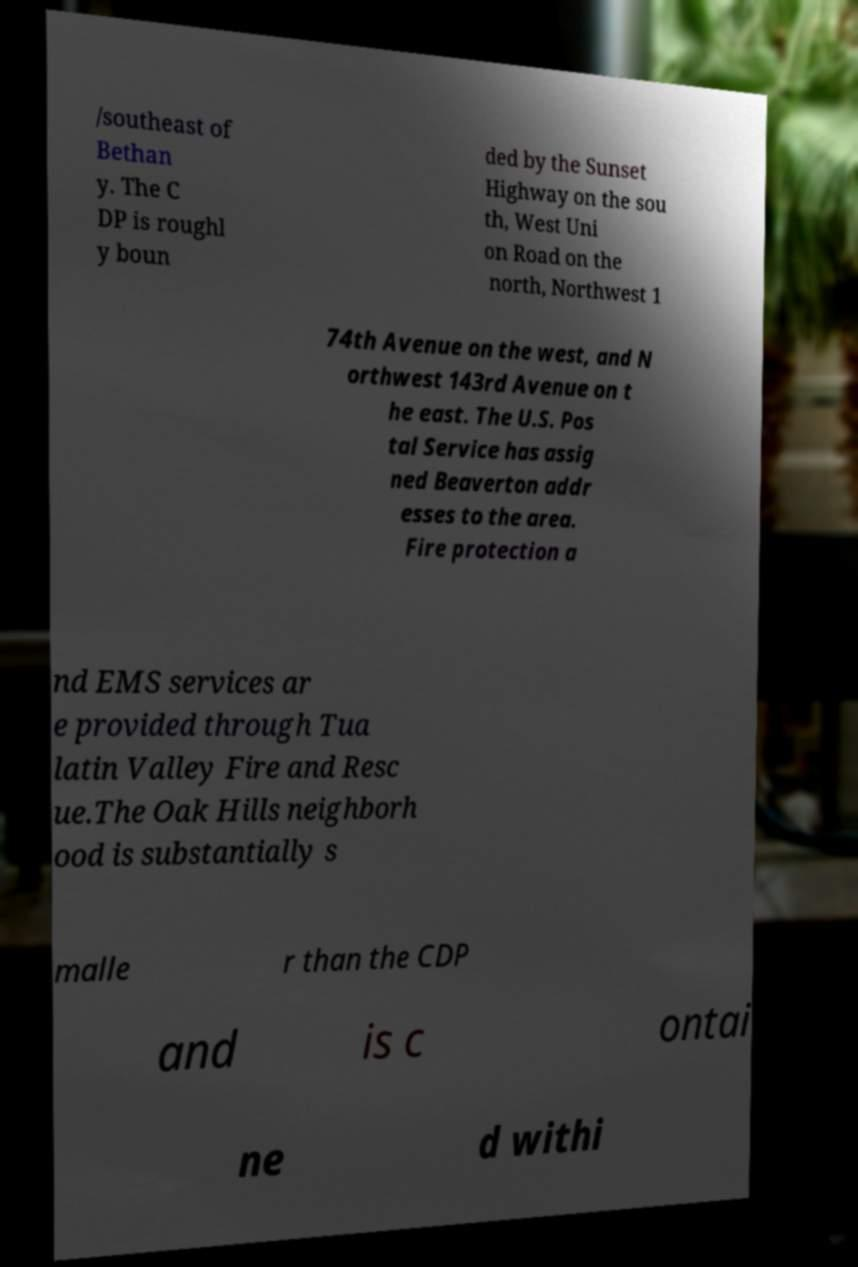Please identify and transcribe the text found in this image. /southeast of Bethan y. The C DP is roughl y boun ded by the Sunset Highway on the sou th, West Uni on Road on the north, Northwest 1 74th Avenue on the west, and N orthwest 143rd Avenue on t he east. The U.S. Pos tal Service has assig ned Beaverton addr esses to the area. Fire protection a nd EMS services ar e provided through Tua latin Valley Fire and Resc ue.The Oak Hills neighborh ood is substantially s malle r than the CDP and is c ontai ne d withi 